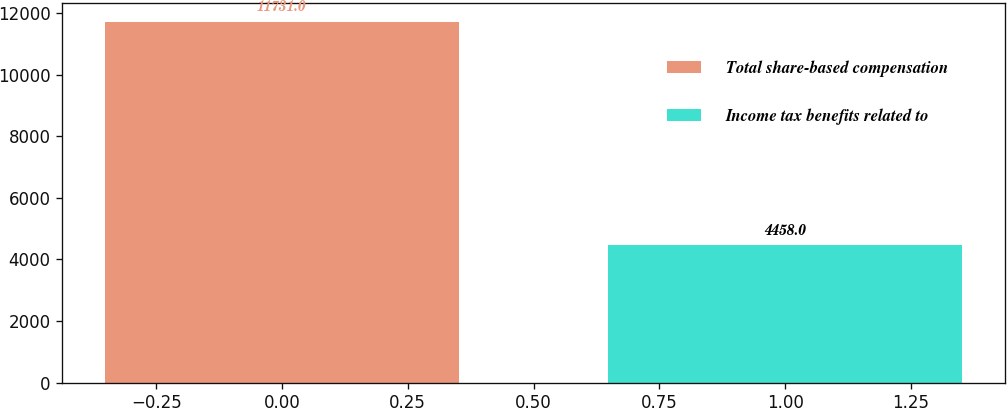<chart> <loc_0><loc_0><loc_500><loc_500><bar_chart><fcel>Total share-based compensation<fcel>Income tax benefits related to<nl><fcel>11731<fcel>4458<nl></chart> 